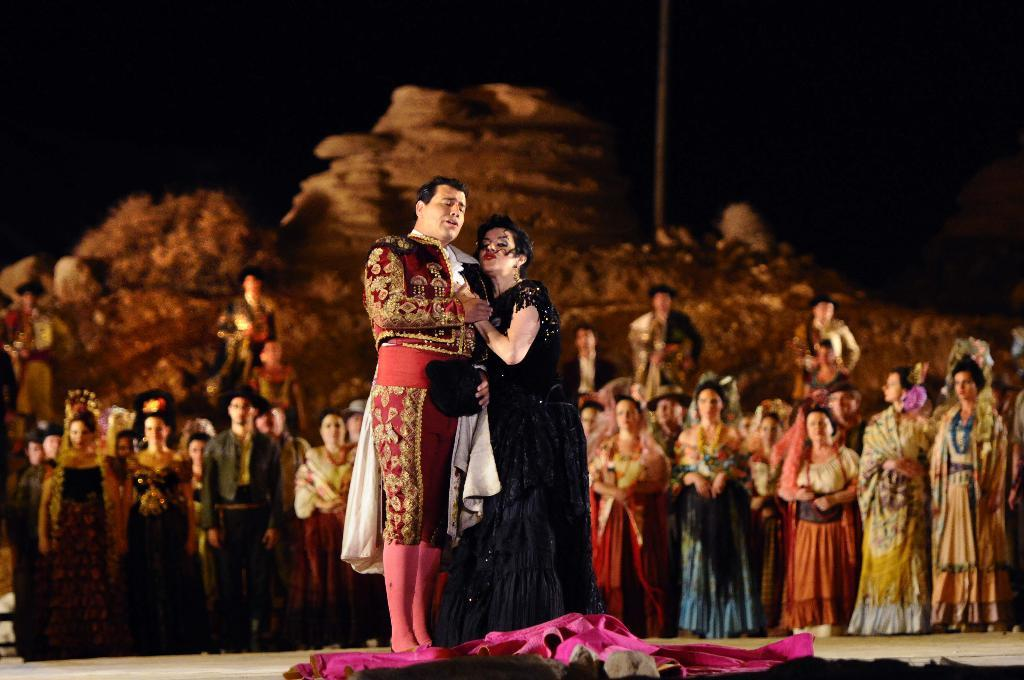How many people are standing in the image? There is a man and a woman standing in the image. What is on the ground near the people? There is a pink cloth on the ground. What can be seen in the background of the image? There is a crowd in the background of the image. How would you describe the lighting in the image? The background is dark. What type of plough is being used by the writer in the image? There is no writer or plough present in the image. How does the twist in the cloth affect the man's stance in the image? There is no twist in the cloth mentioned in the facts, and the man's stance is not affected by any twist. 